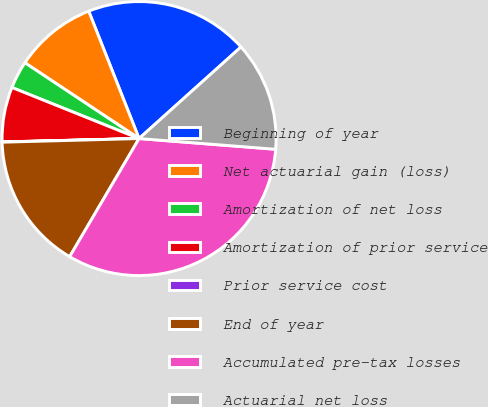Convert chart. <chart><loc_0><loc_0><loc_500><loc_500><pie_chart><fcel>Beginning of year<fcel>Net actuarial gain (loss)<fcel>Amortization of net loss<fcel>Amortization of prior service<fcel>Prior service cost<fcel>End of year<fcel>Accumulated pre-tax losses<fcel>Actuarial net loss<nl><fcel>19.34%<fcel>9.68%<fcel>3.25%<fcel>6.47%<fcel>0.03%<fcel>16.12%<fcel>32.21%<fcel>12.9%<nl></chart> 